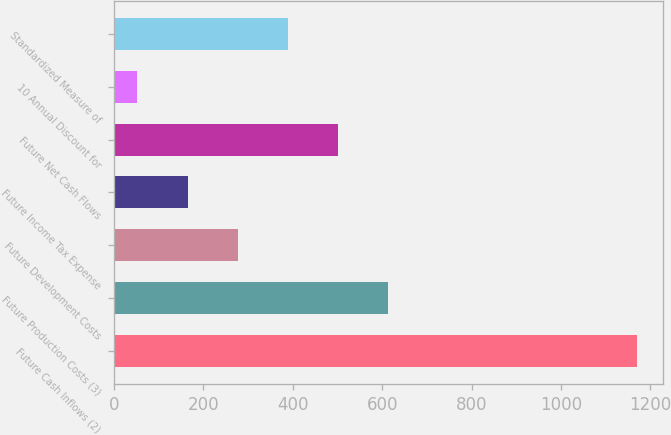<chart> <loc_0><loc_0><loc_500><loc_500><bar_chart><fcel>Future Cash Inflows (2)<fcel>Future Production Costs (3)<fcel>Future Development Costs<fcel>Future Income Tax Expense<fcel>Future Net Cash Flows<fcel>10 Annual Discount for<fcel>Standardized Measure of<nl><fcel>1171<fcel>614<fcel>278<fcel>166<fcel>502<fcel>51<fcel>390<nl></chart> 